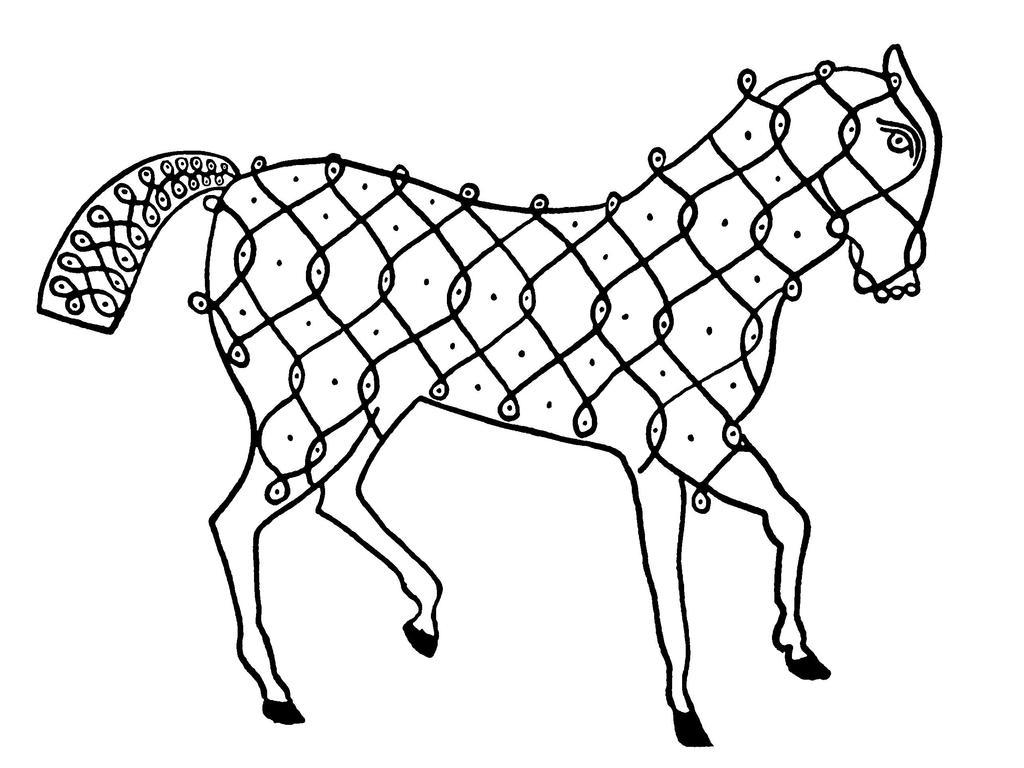What is depicted in the image? There is a drawing of an animal in the image. What color is the background of the image? The background of the image is white. What type of stamp can be seen on the band's merchandise in the image? There is no band or merchandise present in the image; it features a drawing of an animal with a white background. 